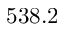Convert formula to latex. <formula><loc_0><loc_0><loc_500><loc_500>5 3 8 . 2</formula> 